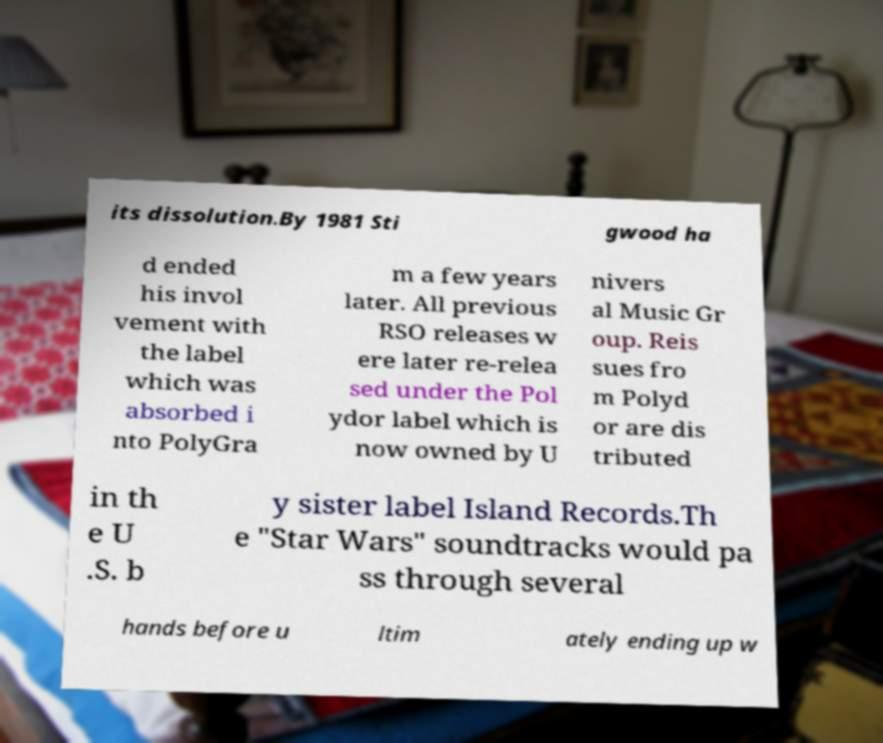Can you read and provide the text displayed in the image?This photo seems to have some interesting text. Can you extract and type it out for me? its dissolution.By 1981 Sti gwood ha d ended his invol vement with the label which was absorbed i nto PolyGra m a few years later. All previous RSO releases w ere later re-relea sed under the Pol ydor label which is now owned by U nivers al Music Gr oup. Reis sues fro m Polyd or are dis tributed in th e U .S. b y sister label Island Records.Th e "Star Wars" soundtracks would pa ss through several hands before u ltim ately ending up w 